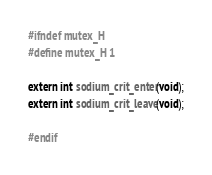Convert code to text. <code><loc_0><loc_0><loc_500><loc_500><_C_>#ifndef mutex_H
#define mutex_H 1

extern int sodium_crit_enter(void);
extern int sodium_crit_leave(void);

#endif
</code> 